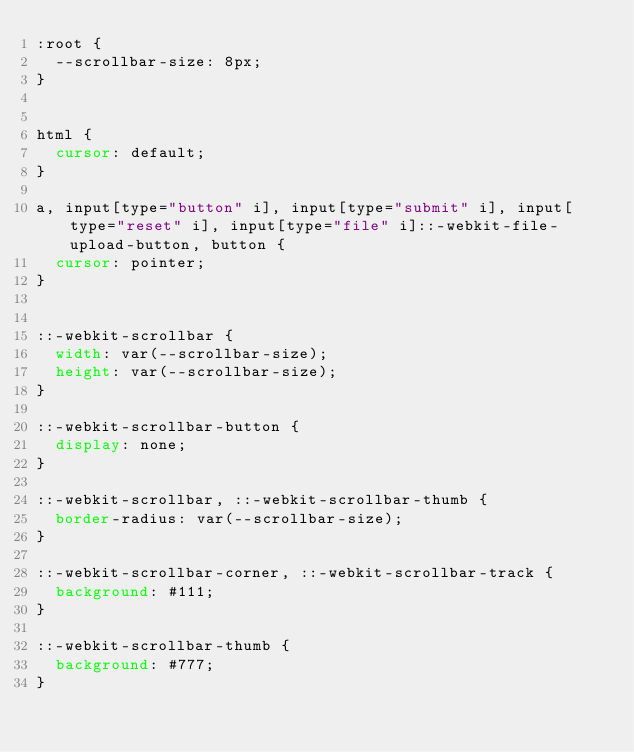Convert code to text. <code><loc_0><loc_0><loc_500><loc_500><_CSS_>:root {
  --scrollbar-size: 8px;
}


html {
  cursor: default;
}

a, input[type="button" i], input[type="submit" i], input[type="reset" i], input[type="file" i]::-webkit-file-upload-button, button {
  cursor: pointer;
}


::-webkit-scrollbar {
  width: var(--scrollbar-size);
  height: var(--scrollbar-size);
}

::-webkit-scrollbar-button {
  display: none;
}

::-webkit-scrollbar, ::-webkit-scrollbar-thumb {
  border-radius: var(--scrollbar-size);
}

::-webkit-scrollbar-corner, ::-webkit-scrollbar-track {
  background: #111;
}

::-webkit-scrollbar-thumb {
  background: #777;
}
</code> 